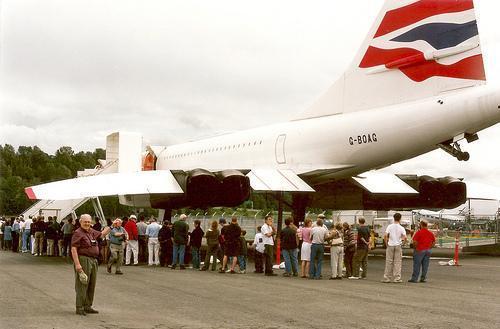How many colors are on the plane?
Give a very brief answer. 3. How many planes are there?
Give a very brief answer. 1. How many engines on wings?
Give a very brief answer. 4. 